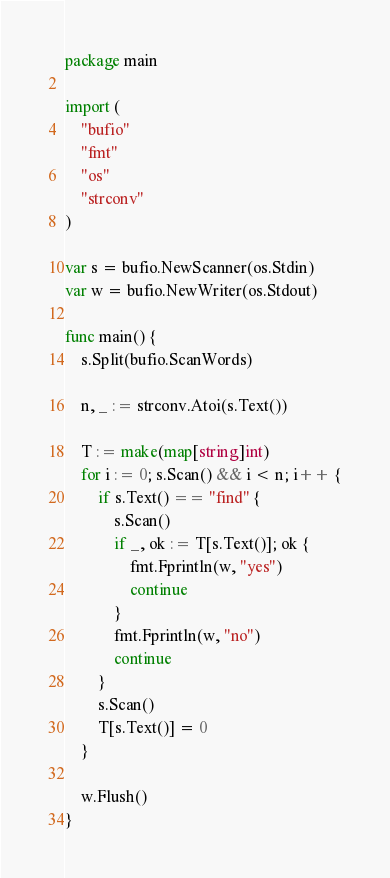<code> <loc_0><loc_0><loc_500><loc_500><_Go_>package main

import (
	"bufio"
	"fmt"
	"os"
	"strconv"
)

var s = bufio.NewScanner(os.Stdin)
var w = bufio.NewWriter(os.Stdout)

func main() {
	s.Split(bufio.ScanWords)

	n, _ := strconv.Atoi(s.Text())

	T := make(map[string]int)
	for i := 0; s.Scan() && i < n; i++ {
		if s.Text() == "find" {
			s.Scan()
			if _, ok := T[s.Text()]; ok {
				fmt.Fprintln(w, "yes")
				continue
			}
			fmt.Fprintln(w, "no")
			continue
		}
		s.Scan()
		T[s.Text()] = 0
	}

	w.Flush()
}

</code> 